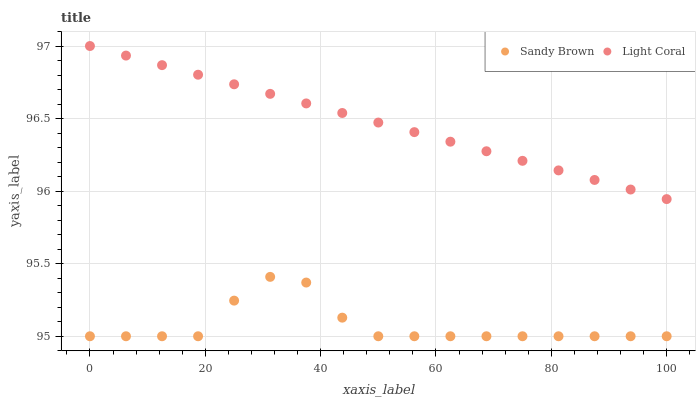Does Sandy Brown have the minimum area under the curve?
Answer yes or no. Yes. Does Light Coral have the maximum area under the curve?
Answer yes or no. Yes. Does Sandy Brown have the maximum area under the curve?
Answer yes or no. No. Is Light Coral the smoothest?
Answer yes or no. Yes. Is Sandy Brown the roughest?
Answer yes or no. Yes. Is Sandy Brown the smoothest?
Answer yes or no. No. Does Sandy Brown have the lowest value?
Answer yes or no. Yes. Does Light Coral have the highest value?
Answer yes or no. Yes. Does Sandy Brown have the highest value?
Answer yes or no. No. Is Sandy Brown less than Light Coral?
Answer yes or no. Yes. Is Light Coral greater than Sandy Brown?
Answer yes or no. Yes. Does Sandy Brown intersect Light Coral?
Answer yes or no. No. 